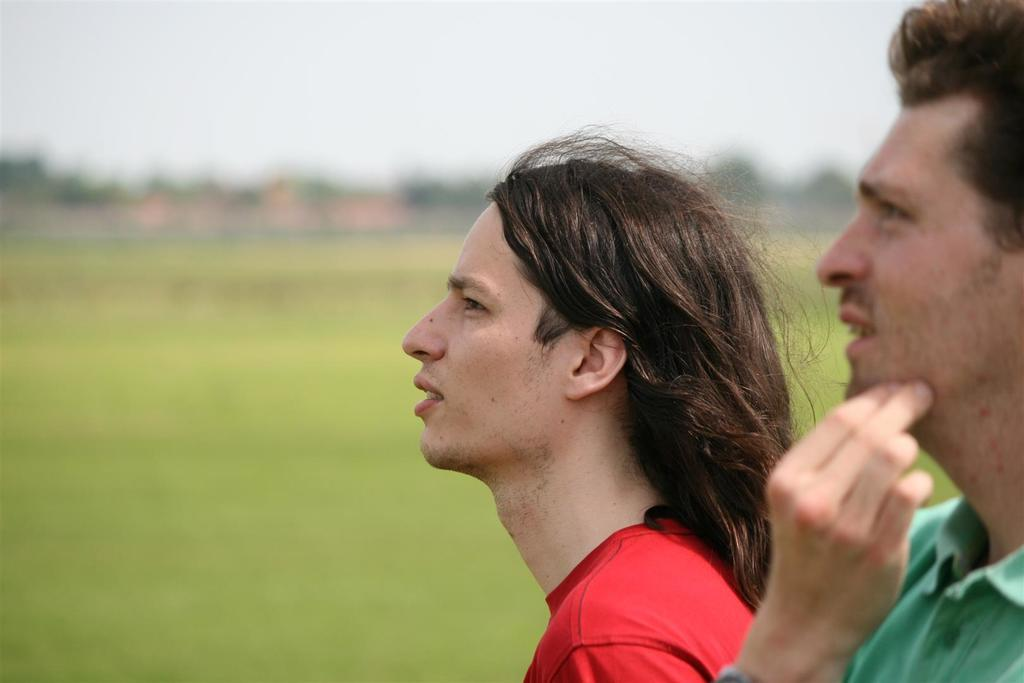How many people are in the foreground of the image? There are two persons in the foreground of the image. What type of ground is visible at the bottom of the image? There is grass at the bottom of the image. Can you describe the background of the image? The background of the image is blurred. How many dolls can be seen playing with the dogs in the image? There are no dolls or dogs present in the image. 